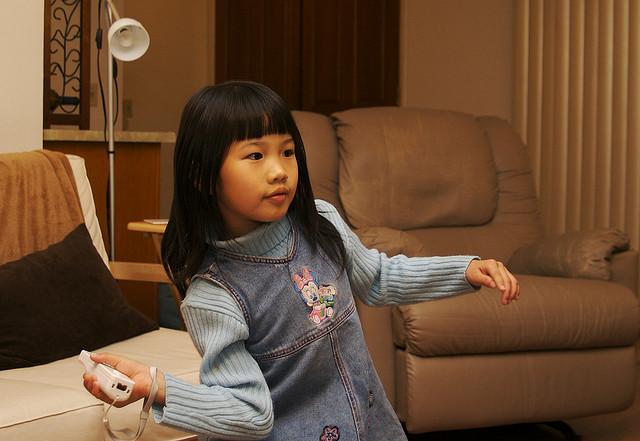Is this lady posing for the picture?
Answer briefly. No. What figure is on the shirt?
Write a very short answer. Minnie mouse. What game device is she holding?
Be succinct. Wii. Is the child left or right handed?
Quick response, please. Right. 